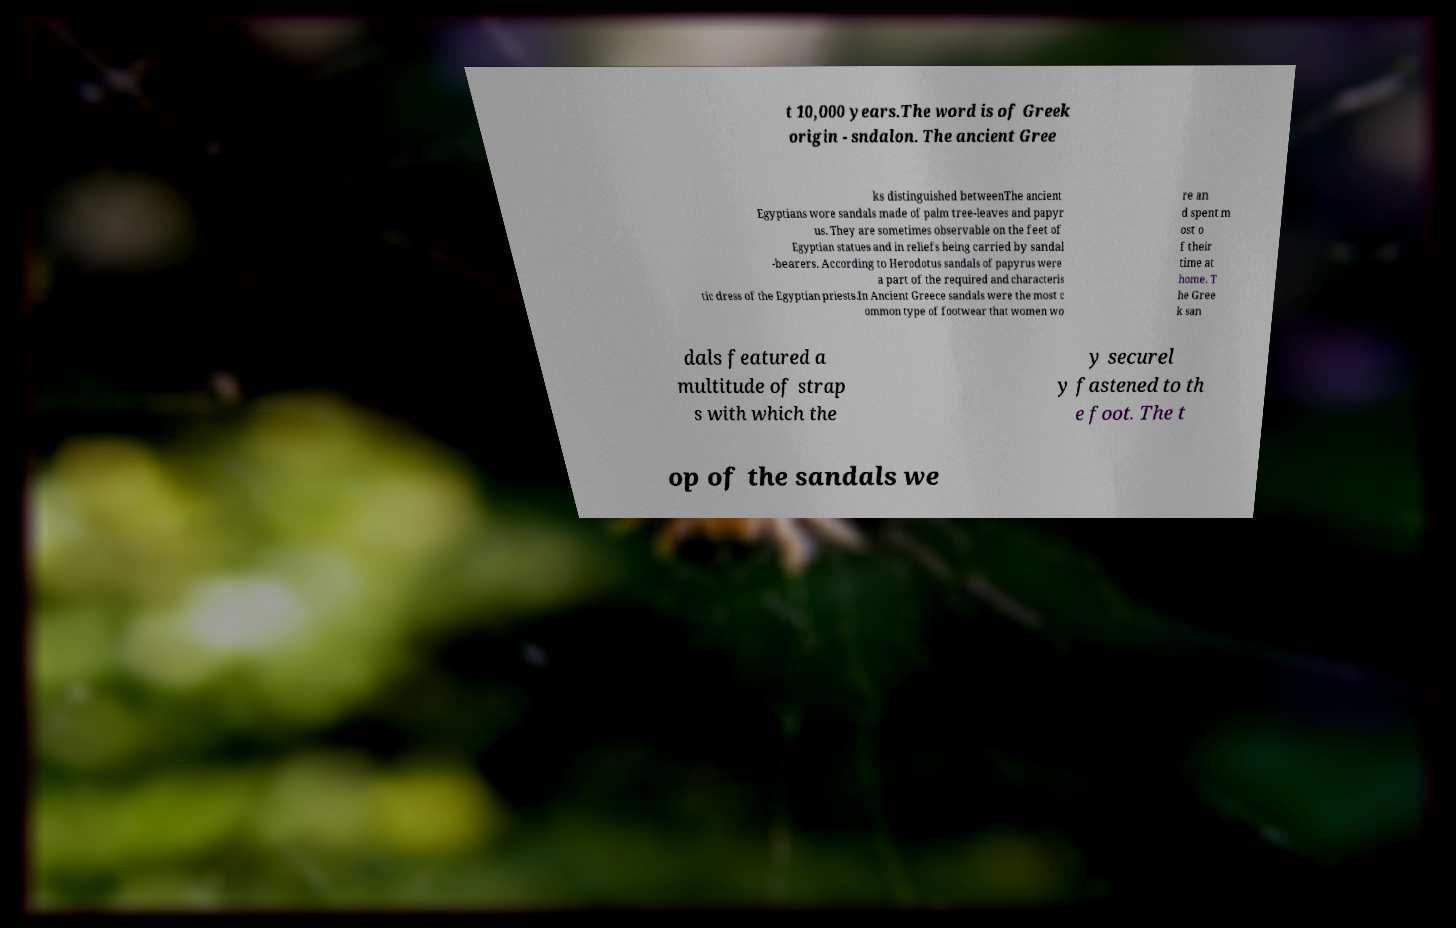Can you accurately transcribe the text from the provided image for me? t 10,000 years.The word is of Greek origin - sndalon. The ancient Gree ks distinguished betweenThe ancient Egyptians wore sandals made of palm tree-leaves and papyr us. They are sometimes observable on the feet of Egyptian statues and in reliefs being carried by sandal -bearers. According to Herodotus sandals of papyrus were a part of the required and characteris tic dress of the Egyptian priests.In Ancient Greece sandals were the most c ommon type of footwear that women wo re an d spent m ost o f their time at home. T he Gree k san dals featured a multitude of strap s with which the y securel y fastened to th e foot. The t op of the sandals we 